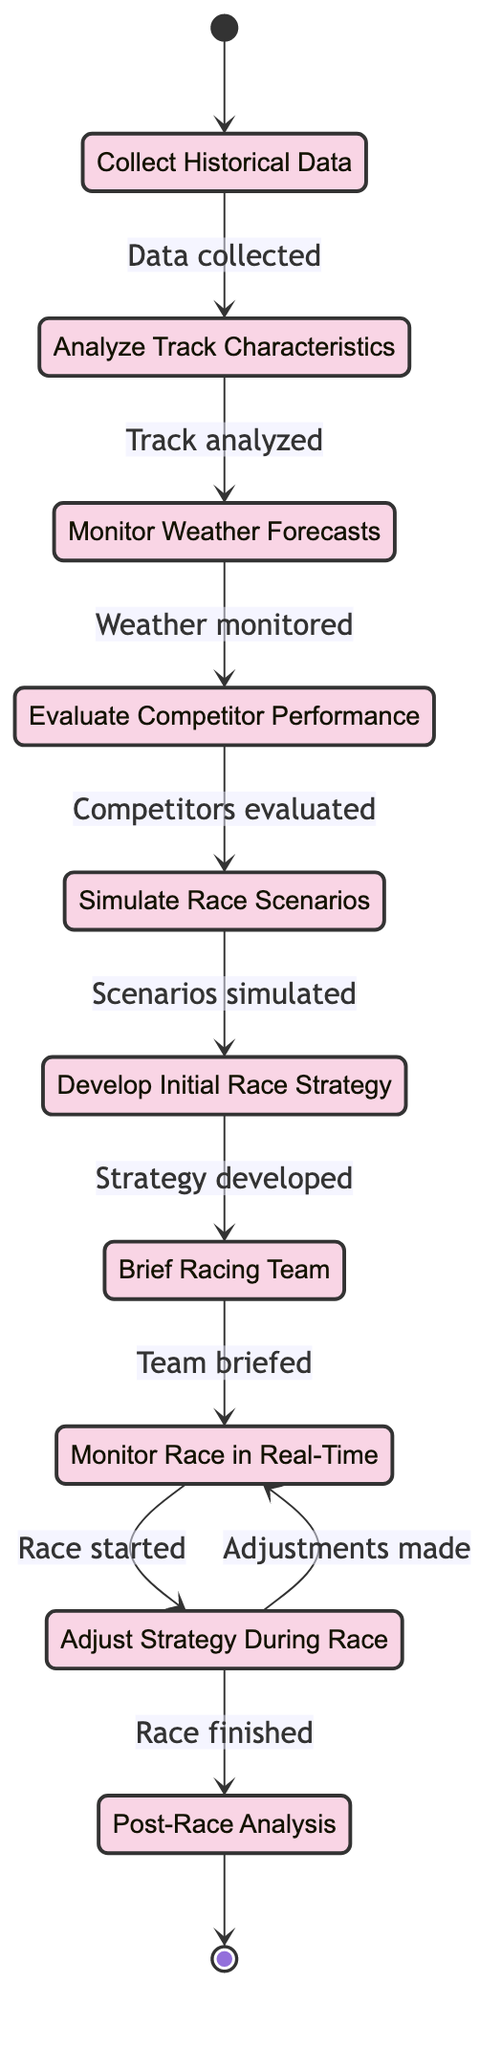What is the first activity in the race strategy development process? The diagram begins with the activity "Collect Historical Data," which is the first step in the process.
Answer: Collect Historical Data How many activities are there in the diagram? By counting the boxes representing different activities, we find there are ten activities listed in the diagram.
Answer: 10 Which activity follows "Monitor Weather Forecasts"? Following "Monitor Weather Forecasts," the next activity is "Evaluate Competitor Performance." This can be determined by looking at the arrows connecting these activities in the diagram.
Answer: Evaluate Competitor Performance What is the last activity in the race strategy development process? The last activity represented in the diagram is "Post-Race Analysis," which occurs after the race is finished.
Answer: Post-Race Analysis Which activity leads to "Simulate Race Scenarios"? The activity that leads to "Simulate Race Scenarios" is "Evaluate Competitor Performance," as indicated by the flow direction in the diagram.
Answer: Evaluate Competitor Performance If the race starts, which activity immediately follows? After the race starts, the immediate next activity is "Adjust Strategy During Race," indicating the need for real-time adjustments based on race events.
Answer: Adjust Strategy During Race How many adjustments can be made during the race? The diagram specifies that adjustments can be made continually during the race as indicated by the two-way arrow between "Monitor Race in Real-Time" and "Adjust Strategy During Race." This suggests multiple adjustments can be made in a loop.
Answer: Multiple What is required before "Develop Initial Race Strategy"? Before "Develop Initial Race Strategy," the prior activities must be completed, specifically, "Simulate Race Scenarios." This is evidenced by the directional flow in the diagram.
Answer: Simulate Race Scenarios 